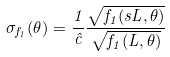<formula> <loc_0><loc_0><loc_500><loc_500>\sigma _ { f _ { 1 } } ( \theta ) = \frac { 1 } { \hat { c } } \frac { \sqrt { f _ { 1 } ( s L , \theta ) } } { \sqrt { f _ { 1 } ( L , \theta ) } }</formula> 